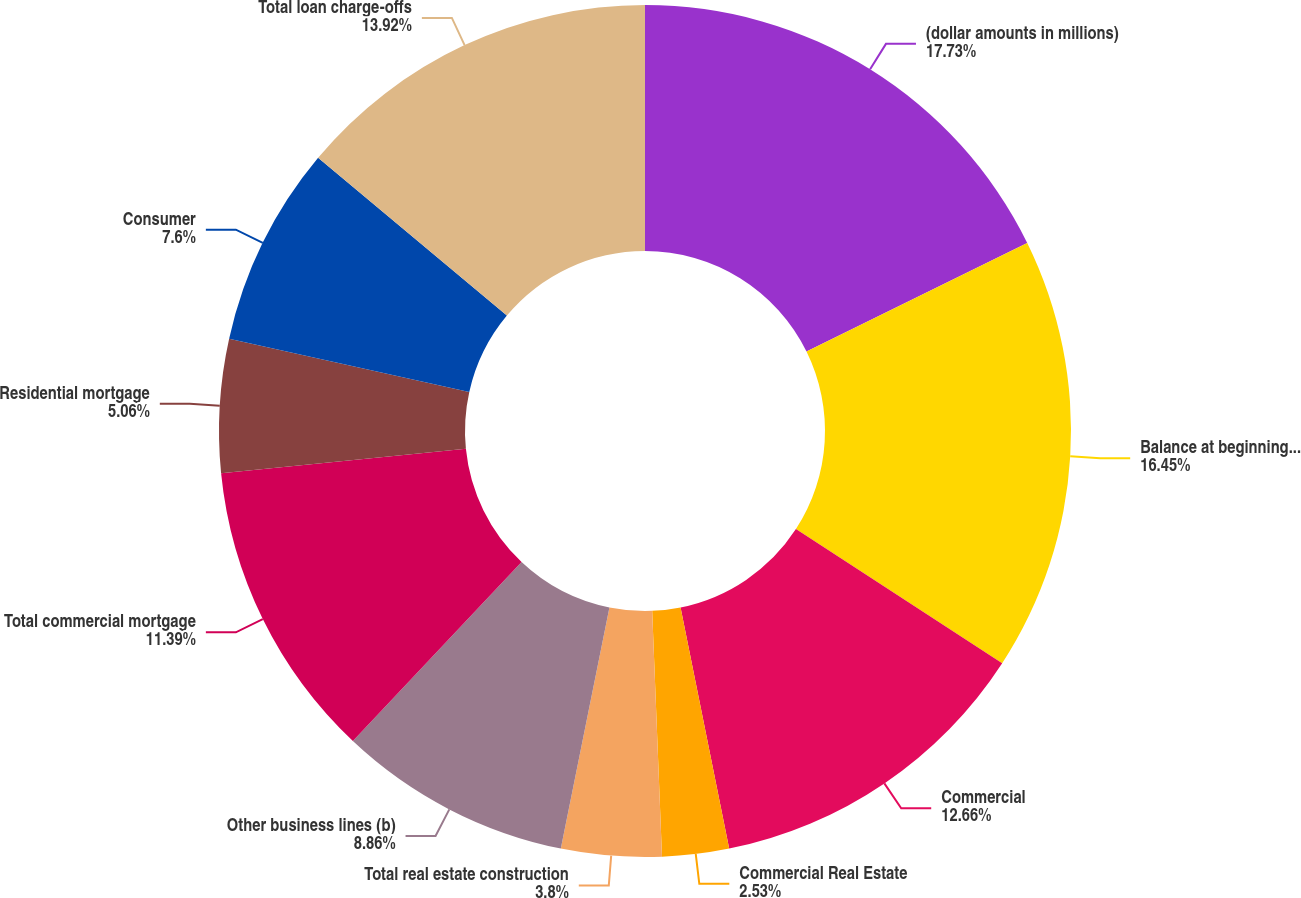Convert chart. <chart><loc_0><loc_0><loc_500><loc_500><pie_chart><fcel>(dollar amounts in millions)<fcel>Balance at beginning of year<fcel>Commercial<fcel>Commercial Real Estate<fcel>Total real estate construction<fcel>Other business lines (b)<fcel>Total commercial mortgage<fcel>Residential mortgage<fcel>Consumer<fcel>Total loan charge-offs<nl><fcel>17.72%<fcel>16.45%<fcel>12.66%<fcel>2.53%<fcel>3.8%<fcel>8.86%<fcel>11.39%<fcel>5.06%<fcel>7.6%<fcel>13.92%<nl></chart> 